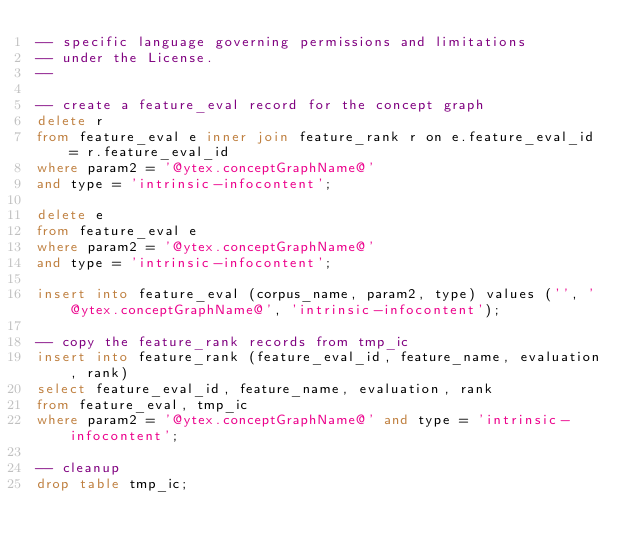Convert code to text. <code><loc_0><loc_0><loc_500><loc_500><_SQL_>-- specific language governing permissions and limitations
-- under the License.
--

-- create a feature_eval record for the concept graph
delete r
from feature_eval e inner join feature_rank r on e.feature_eval_id = r.feature_eval_id
where param2 = '@ytex.conceptGraphName@' 
and type = 'intrinsic-infocontent';

delete e
from feature_eval e
where param2 = '@ytex.conceptGraphName@' 
and type = 'intrinsic-infocontent';

insert into feature_eval (corpus_name, param2, type) values ('', '@ytex.conceptGraphName@', 'intrinsic-infocontent');

-- copy the feature_rank records from tmp_ic
insert into feature_rank (feature_eval_id, feature_name, evaluation, rank)
select feature_eval_id, feature_name, evaluation, rank
from feature_eval, tmp_ic
where param2 = '@ytex.conceptGraphName@' and type = 'intrinsic-infocontent';

-- cleanup
drop table tmp_ic;</code> 